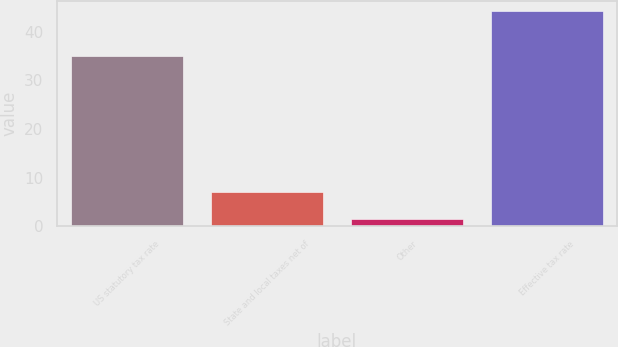Convert chart. <chart><loc_0><loc_0><loc_500><loc_500><bar_chart><fcel>US statutory tax rate<fcel>State and local taxes net of<fcel>Other<fcel>Effective tax rate<nl><fcel>35<fcel>7<fcel>1.5<fcel>44.2<nl></chart> 